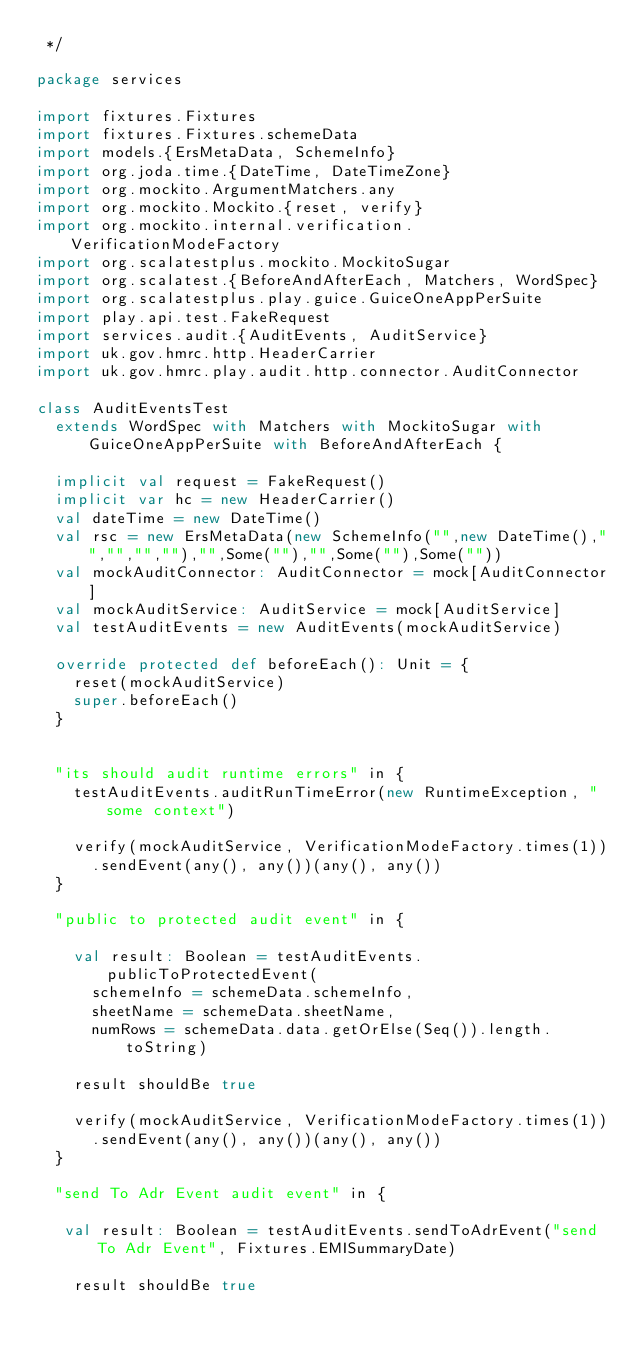Convert code to text. <code><loc_0><loc_0><loc_500><loc_500><_Scala_> */

package services

import fixtures.Fixtures
import fixtures.Fixtures.schemeData
import models.{ErsMetaData, SchemeInfo}
import org.joda.time.{DateTime, DateTimeZone}
import org.mockito.ArgumentMatchers.any
import org.mockito.Mockito.{reset, verify}
import org.mockito.internal.verification.VerificationModeFactory
import org.scalatestplus.mockito.MockitoSugar
import org.scalatest.{BeforeAndAfterEach, Matchers, WordSpec}
import org.scalatestplus.play.guice.GuiceOneAppPerSuite
import play.api.test.FakeRequest
import services.audit.{AuditEvents, AuditService}
import uk.gov.hmrc.http.HeaderCarrier
import uk.gov.hmrc.play.audit.http.connector.AuditConnector

class AuditEventsTest
  extends WordSpec with Matchers with MockitoSugar with GuiceOneAppPerSuite with BeforeAndAfterEach {

  implicit val request = FakeRequest()
  implicit var hc = new HeaderCarrier()
  val dateTime = new DateTime()
  val rsc = new ErsMetaData(new SchemeInfo("",new DateTime(),"","","",""),"",Some(""),"",Some(""),Some(""))
  val mockAuditConnector: AuditConnector = mock[AuditConnector]
  val mockAuditService: AuditService = mock[AuditService]
  val testAuditEvents = new AuditEvents(mockAuditService)

  override protected def beforeEach(): Unit = {
    reset(mockAuditService)
    super.beforeEach()
  }


  "its should audit runtime errors" in {
    testAuditEvents.auditRunTimeError(new RuntimeException, "some context")

    verify(mockAuditService, VerificationModeFactory.times(1))
      .sendEvent(any(), any())(any(), any())
  }

  "public to protected audit event" in {

    val result: Boolean = testAuditEvents.publicToProtectedEvent(
      schemeInfo = schemeData.schemeInfo,
      sheetName = schemeData.sheetName,
      numRows = schemeData.data.getOrElse(Seq()).length.toString)

    result shouldBe true

    verify(mockAuditService, VerificationModeFactory.times(1))
      .sendEvent(any(), any())(any(), any())
  }

  "send To Adr Event audit event" in {

   val result: Boolean = testAuditEvents.sendToAdrEvent("send To Adr Event", Fixtures.EMISummaryDate)

    result shouldBe true</code> 